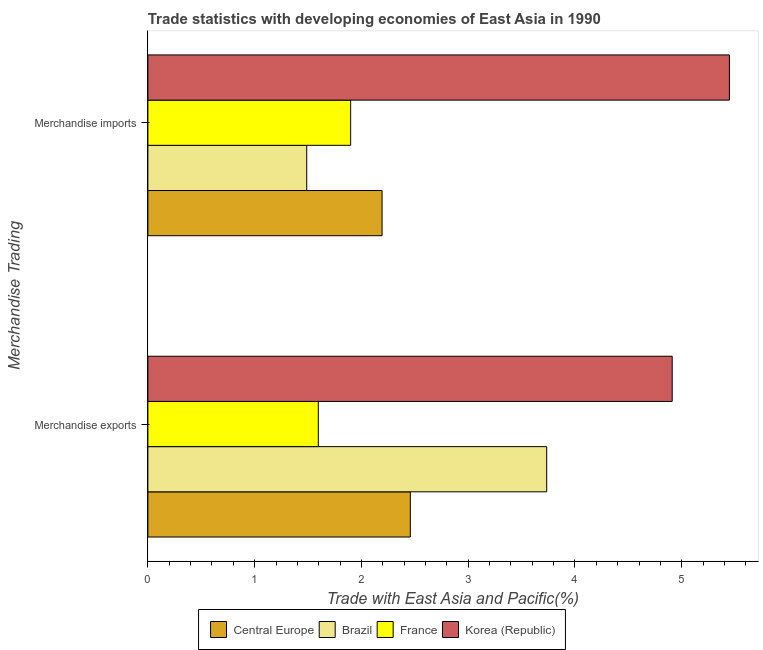How many different coloured bars are there?
Provide a succinct answer. 4. How many bars are there on the 1st tick from the top?
Offer a very short reply. 4. How many bars are there on the 1st tick from the bottom?
Ensure brevity in your answer.  4. What is the merchandise exports in Central Europe?
Your answer should be compact. 2.46. Across all countries, what is the maximum merchandise exports?
Provide a short and direct response. 4.91. Across all countries, what is the minimum merchandise exports?
Give a very brief answer. 1.6. What is the total merchandise imports in the graph?
Provide a succinct answer. 11.03. What is the difference between the merchandise exports in Brazil and that in France?
Your answer should be compact. 2.14. What is the difference between the merchandise exports in Korea (Republic) and the merchandise imports in Central Europe?
Your answer should be very brief. 2.72. What is the average merchandise imports per country?
Offer a very short reply. 2.76. What is the difference between the merchandise exports and merchandise imports in Korea (Republic)?
Make the answer very short. -0.54. In how many countries, is the merchandise imports greater than 3.8 %?
Make the answer very short. 1. What is the ratio of the merchandise imports in Korea (Republic) to that in France?
Make the answer very short. 2.87. In how many countries, is the merchandise imports greater than the average merchandise imports taken over all countries?
Your response must be concise. 1. What does the 3rd bar from the bottom in Merchandise imports represents?
Offer a terse response. France. How many bars are there?
Your answer should be very brief. 8. What is the difference between two consecutive major ticks on the X-axis?
Provide a succinct answer. 1. Does the graph contain grids?
Offer a terse response. No. How are the legend labels stacked?
Keep it short and to the point. Horizontal. What is the title of the graph?
Make the answer very short. Trade statistics with developing economies of East Asia in 1990. What is the label or title of the X-axis?
Provide a succinct answer. Trade with East Asia and Pacific(%). What is the label or title of the Y-axis?
Offer a terse response. Merchandise Trading. What is the Trade with East Asia and Pacific(%) of Central Europe in Merchandise exports?
Give a very brief answer. 2.46. What is the Trade with East Asia and Pacific(%) of Brazil in Merchandise exports?
Give a very brief answer. 3.74. What is the Trade with East Asia and Pacific(%) in France in Merchandise exports?
Your answer should be compact. 1.6. What is the Trade with East Asia and Pacific(%) of Korea (Republic) in Merchandise exports?
Offer a very short reply. 4.91. What is the Trade with East Asia and Pacific(%) of Central Europe in Merchandise imports?
Keep it short and to the point. 2.19. What is the Trade with East Asia and Pacific(%) in Brazil in Merchandise imports?
Offer a very short reply. 1.49. What is the Trade with East Asia and Pacific(%) in France in Merchandise imports?
Offer a very short reply. 1.9. What is the Trade with East Asia and Pacific(%) in Korea (Republic) in Merchandise imports?
Provide a succinct answer. 5.45. Across all Merchandise Trading, what is the maximum Trade with East Asia and Pacific(%) in Central Europe?
Your answer should be very brief. 2.46. Across all Merchandise Trading, what is the maximum Trade with East Asia and Pacific(%) of Brazil?
Keep it short and to the point. 3.74. Across all Merchandise Trading, what is the maximum Trade with East Asia and Pacific(%) of France?
Your answer should be very brief. 1.9. Across all Merchandise Trading, what is the maximum Trade with East Asia and Pacific(%) in Korea (Republic)?
Ensure brevity in your answer.  5.45. Across all Merchandise Trading, what is the minimum Trade with East Asia and Pacific(%) in Central Europe?
Your answer should be compact. 2.19. Across all Merchandise Trading, what is the minimum Trade with East Asia and Pacific(%) in Brazil?
Provide a succinct answer. 1.49. Across all Merchandise Trading, what is the minimum Trade with East Asia and Pacific(%) in France?
Make the answer very short. 1.6. Across all Merchandise Trading, what is the minimum Trade with East Asia and Pacific(%) in Korea (Republic)?
Provide a short and direct response. 4.91. What is the total Trade with East Asia and Pacific(%) of Central Europe in the graph?
Make the answer very short. 4.65. What is the total Trade with East Asia and Pacific(%) in Brazil in the graph?
Provide a short and direct response. 5.22. What is the total Trade with East Asia and Pacific(%) of France in the graph?
Ensure brevity in your answer.  3.5. What is the total Trade with East Asia and Pacific(%) in Korea (Republic) in the graph?
Your answer should be very brief. 10.36. What is the difference between the Trade with East Asia and Pacific(%) of Central Europe in Merchandise exports and that in Merchandise imports?
Keep it short and to the point. 0.26. What is the difference between the Trade with East Asia and Pacific(%) in Brazil in Merchandise exports and that in Merchandise imports?
Your answer should be very brief. 2.25. What is the difference between the Trade with East Asia and Pacific(%) of France in Merchandise exports and that in Merchandise imports?
Make the answer very short. -0.3. What is the difference between the Trade with East Asia and Pacific(%) of Korea (Republic) in Merchandise exports and that in Merchandise imports?
Your answer should be very brief. -0.54. What is the difference between the Trade with East Asia and Pacific(%) of Central Europe in Merchandise exports and the Trade with East Asia and Pacific(%) of Brazil in Merchandise imports?
Make the answer very short. 0.97. What is the difference between the Trade with East Asia and Pacific(%) of Central Europe in Merchandise exports and the Trade with East Asia and Pacific(%) of France in Merchandise imports?
Your answer should be very brief. 0.56. What is the difference between the Trade with East Asia and Pacific(%) of Central Europe in Merchandise exports and the Trade with East Asia and Pacific(%) of Korea (Republic) in Merchandise imports?
Your answer should be compact. -2.99. What is the difference between the Trade with East Asia and Pacific(%) in Brazil in Merchandise exports and the Trade with East Asia and Pacific(%) in France in Merchandise imports?
Your answer should be very brief. 1.84. What is the difference between the Trade with East Asia and Pacific(%) of Brazil in Merchandise exports and the Trade with East Asia and Pacific(%) of Korea (Republic) in Merchandise imports?
Offer a very short reply. -1.71. What is the difference between the Trade with East Asia and Pacific(%) of France in Merchandise exports and the Trade with East Asia and Pacific(%) of Korea (Republic) in Merchandise imports?
Offer a very short reply. -3.85. What is the average Trade with East Asia and Pacific(%) of Central Europe per Merchandise Trading?
Your response must be concise. 2.33. What is the average Trade with East Asia and Pacific(%) of Brazil per Merchandise Trading?
Your response must be concise. 2.61. What is the average Trade with East Asia and Pacific(%) in France per Merchandise Trading?
Offer a terse response. 1.75. What is the average Trade with East Asia and Pacific(%) in Korea (Republic) per Merchandise Trading?
Your answer should be compact. 5.18. What is the difference between the Trade with East Asia and Pacific(%) of Central Europe and Trade with East Asia and Pacific(%) of Brazil in Merchandise exports?
Your answer should be compact. -1.28. What is the difference between the Trade with East Asia and Pacific(%) of Central Europe and Trade with East Asia and Pacific(%) of France in Merchandise exports?
Your response must be concise. 0.86. What is the difference between the Trade with East Asia and Pacific(%) in Central Europe and Trade with East Asia and Pacific(%) in Korea (Republic) in Merchandise exports?
Keep it short and to the point. -2.45. What is the difference between the Trade with East Asia and Pacific(%) in Brazil and Trade with East Asia and Pacific(%) in France in Merchandise exports?
Provide a succinct answer. 2.14. What is the difference between the Trade with East Asia and Pacific(%) of Brazil and Trade with East Asia and Pacific(%) of Korea (Republic) in Merchandise exports?
Give a very brief answer. -1.18. What is the difference between the Trade with East Asia and Pacific(%) in France and Trade with East Asia and Pacific(%) in Korea (Republic) in Merchandise exports?
Your answer should be compact. -3.31. What is the difference between the Trade with East Asia and Pacific(%) of Central Europe and Trade with East Asia and Pacific(%) of Brazil in Merchandise imports?
Make the answer very short. 0.71. What is the difference between the Trade with East Asia and Pacific(%) of Central Europe and Trade with East Asia and Pacific(%) of France in Merchandise imports?
Give a very brief answer. 0.29. What is the difference between the Trade with East Asia and Pacific(%) of Central Europe and Trade with East Asia and Pacific(%) of Korea (Republic) in Merchandise imports?
Offer a terse response. -3.25. What is the difference between the Trade with East Asia and Pacific(%) of Brazil and Trade with East Asia and Pacific(%) of France in Merchandise imports?
Your answer should be very brief. -0.41. What is the difference between the Trade with East Asia and Pacific(%) in Brazil and Trade with East Asia and Pacific(%) in Korea (Republic) in Merchandise imports?
Give a very brief answer. -3.96. What is the difference between the Trade with East Asia and Pacific(%) in France and Trade with East Asia and Pacific(%) in Korea (Republic) in Merchandise imports?
Your response must be concise. -3.55. What is the ratio of the Trade with East Asia and Pacific(%) in Central Europe in Merchandise exports to that in Merchandise imports?
Ensure brevity in your answer.  1.12. What is the ratio of the Trade with East Asia and Pacific(%) of Brazil in Merchandise exports to that in Merchandise imports?
Offer a terse response. 2.51. What is the ratio of the Trade with East Asia and Pacific(%) of France in Merchandise exports to that in Merchandise imports?
Offer a very short reply. 0.84. What is the ratio of the Trade with East Asia and Pacific(%) of Korea (Republic) in Merchandise exports to that in Merchandise imports?
Provide a short and direct response. 0.9. What is the difference between the highest and the second highest Trade with East Asia and Pacific(%) in Central Europe?
Your response must be concise. 0.26. What is the difference between the highest and the second highest Trade with East Asia and Pacific(%) in Brazil?
Give a very brief answer. 2.25. What is the difference between the highest and the second highest Trade with East Asia and Pacific(%) of France?
Keep it short and to the point. 0.3. What is the difference between the highest and the second highest Trade with East Asia and Pacific(%) in Korea (Republic)?
Your answer should be compact. 0.54. What is the difference between the highest and the lowest Trade with East Asia and Pacific(%) in Central Europe?
Make the answer very short. 0.26. What is the difference between the highest and the lowest Trade with East Asia and Pacific(%) in Brazil?
Provide a succinct answer. 2.25. What is the difference between the highest and the lowest Trade with East Asia and Pacific(%) in France?
Your answer should be compact. 0.3. What is the difference between the highest and the lowest Trade with East Asia and Pacific(%) in Korea (Republic)?
Give a very brief answer. 0.54. 